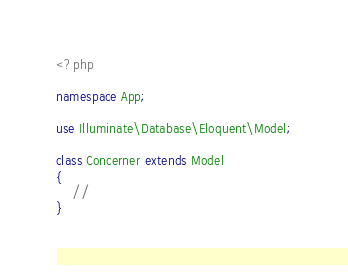Convert code to text. <code><loc_0><loc_0><loc_500><loc_500><_PHP_><?php

namespace App;

use Illuminate\Database\Eloquent\Model;

class Concerner extends Model
{
    //
}
</code> 